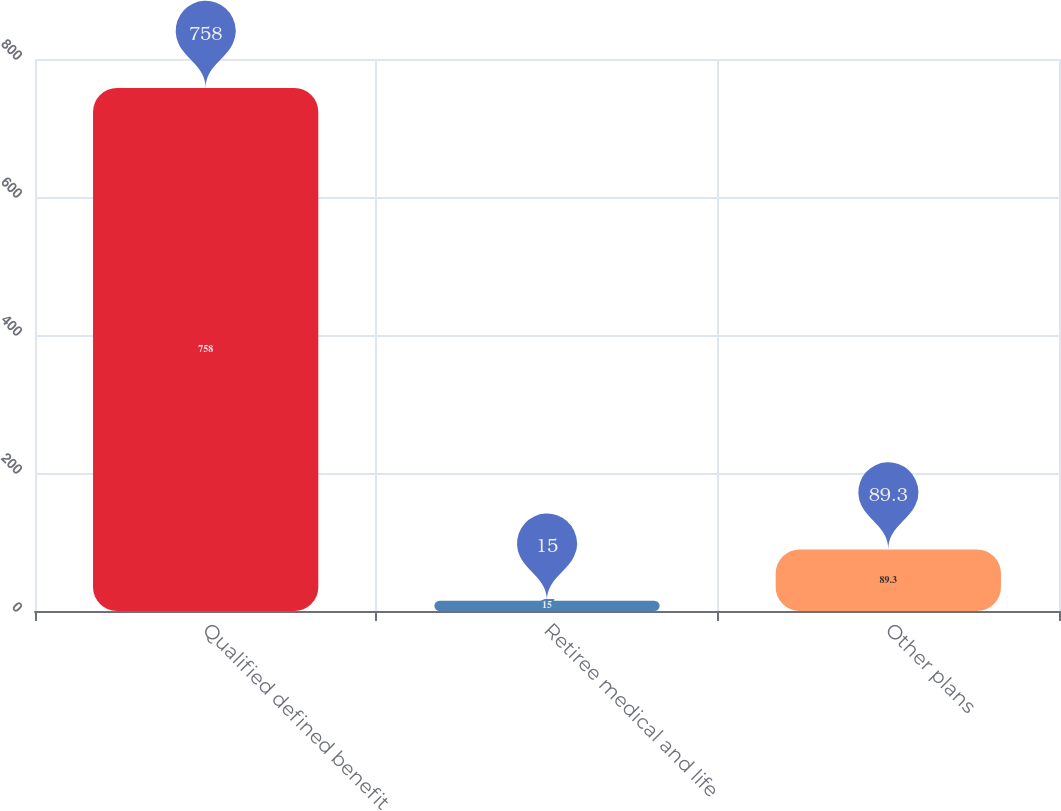Convert chart. <chart><loc_0><loc_0><loc_500><loc_500><bar_chart><fcel>Qualified defined benefit<fcel>Retiree medical and life<fcel>Other plans<nl><fcel>758<fcel>15<fcel>89.3<nl></chart> 